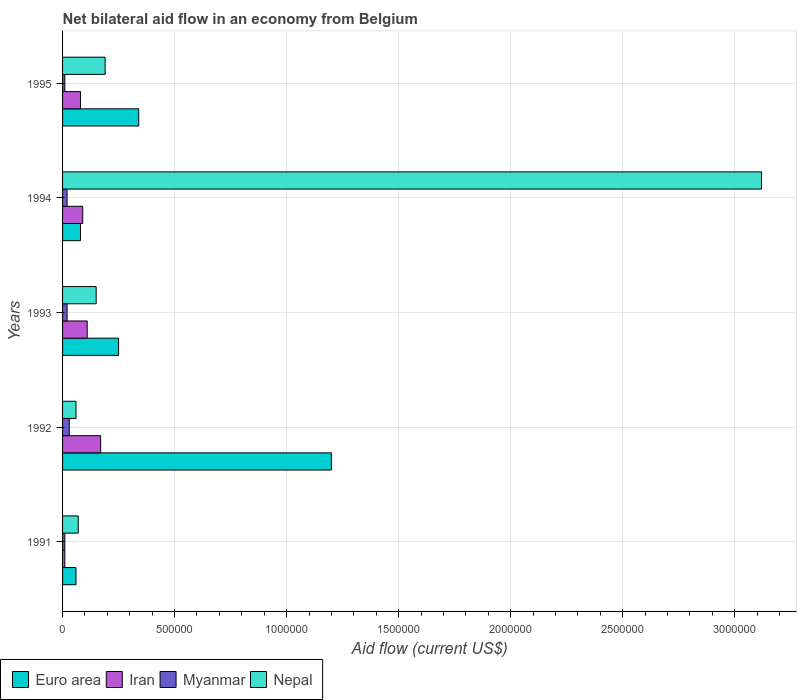How many different coloured bars are there?
Your answer should be compact. 4. How many groups of bars are there?
Your response must be concise. 5. How many bars are there on the 4th tick from the top?
Provide a short and direct response. 4. How many bars are there on the 5th tick from the bottom?
Keep it short and to the point. 4. In how many cases, is the number of bars for a given year not equal to the number of legend labels?
Provide a succinct answer. 0. Across all years, what is the maximum net bilateral aid flow in Nepal?
Make the answer very short. 3.12e+06. Across all years, what is the minimum net bilateral aid flow in Euro area?
Provide a short and direct response. 6.00e+04. In which year was the net bilateral aid flow in Myanmar maximum?
Offer a terse response. 1992. In which year was the net bilateral aid flow in Myanmar minimum?
Offer a terse response. 1991. What is the total net bilateral aid flow in Iran in the graph?
Make the answer very short. 4.60e+05. What is the difference between the net bilateral aid flow in Euro area in 1992 and that in 1995?
Offer a very short reply. 8.60e+05. What is the average net bilateral aid flow in Nepal per year?
Your answer should be very brief. 7.18e+05. What is the ratio of the net bilateral aid flow in Euro area in 1991 to that in 1994?
Provide a short and direct response. 0.75. Is the net bilateral aid flow in Nepal in 1991 less than that in 1994?
Give a very brief answer. Yes. Is the difference between the net bilateral aid flow in Iran in 1994 and 1995 greater than the difference between the net bilateral aid flow in Myanmar in 1994 and 1995?
Provide a short and direct response. No. What is the difference between the highest and the second highest net bilateral aid flow in Euro area?
Provide a short and direct response. 8.60e+05. What is the difference between the highest and the lowest net bilateral aid flow in Iran?
Keep it short and to the point. 1.60e+05. Is it the case that in every year, the sum of the net bilateral aid flow in Euro area and net bilateral aid flow in Myanmar is greater than the sum of net bilateral aid flow in Iran and net bilateral aid flow in Nepal?
Your response must be concise. Yes. What does the 2nd bar from the top in 1994 represents?
Your answer should be very brief. Myanmar. What does the 2nd bar from the bottom in 1993 represents?
Make the answer very short. Iran. Is it the case that in every year, the sum of the net bilateral aid flow in Nepal and net bilateral aid flow in Euro area is greater than the net bilateral aid flow in Iran?
Your answer should be compact. Yes. How many bars are there?
Your answer should be very brief. 20. Are the values on the major ticks of X-axis written in scientific E-notation?
Your response must be concise. No. Does the graph contain any zero values?
Your answer should be compact. No. Does the graph contain grids?
Keep it short and to the point. Yes. How many legend labels are there?
Provide a succinct answer. 4. What is the title of the graph?
Offer a very short reply. Net bilateral aid flow in an economy from Belgium. What is the label or title of the X-axis?
Give a very brief answer. Aid flow (current US$). What is the Aid flow (current US$) in Euro area in 1991?
Offer a very short reply. 6.00e+04. What is the Aid flow (current US$) of Euro area in 1992?
Make the answer very short. 1.20e+06. What is the Aid flow (current US$) in Nepal in 1992?
Offer a terse response. 6.00e+04. What is the Aid flow (current US$) in Euro area in 1993?
Offer a very short reply. 2.50e+05. What is the Aid flow (current US$) in Myanmar in 1993?
Offer a terse response. 2.00e+04. What is the Aid flow (current US$) in Nepal in 1993?
Your response must be concise. 1.50e+05. What is the Aid flow (current US$) of Myanmar in 1994?
Your response must be concise. 2.00e+04. What is the Aid flow (current US$) in Nepal in 1994?
Offer a terse response. 3.12e+06. What is the Aid flow (current US$) in Nepal in 1995?
Give a very brief answer. 1.90e+05. Across all years, what is the maximum Aid flow (current US$) in Euro area?
Ensure brevity in your answer.  1.20e+06. Across all years, what is the maximum Aid flow (current US$) in Myanmar?
Offer a terse response. 3.00e+04. Across all years, what is the maximum Aid flow (current US$) in Nepal?
Your answer should be very brief. 3.12e+06. Across all years, what is the minimum Aid flow (current US$) of Euro area?
Provide a succinct answer. 6.00e+04. Across all years, what is the minimum Aid flow (current US$) of Iran?
Your answer should be compact. 10000. Across all years, what is the minimum Aid flow (current US$) of Nepal?
Your response must be concise. 6.00e+04. What is the total Aid flow (current US$) of Euro area in the graph?
Your answer should be compact. 1.93e+06. What is the total Aid flow (current US$) in Myanmar in the graph?
Your response must be concise. 9.00e+04. What is the total Aid flow (current US$) in Nepal in the graph?
Offer a terse response. 3.59e+06. What is the difference between the Aid flow (current US$) of Euro area in 1991 and that in 1992?
Offer a terse response. -1.14e+06. What is the difference between the Aid flow (current US$) in Iran in 1991 and that in 1992?
Offer a terse response. -1.60e+05. What is the difference between the Aid flow (current US$) of Nepal in 1991 and that in 1993?
Offer a very short reply. -8.00e+04. What is the difference between the Aid flow (current US$) in Euro area in 1991 and that in 1994?
Offer a very short reply. -2.00e+04. What is the difference between the Aid flow (current US$) of Iran in 1991 and that in 1994?
Keep it short and to the point. -8.00e+04. What is the difference between the Aid flow (current US$) in Myanmar in 1991 and that in 1994?
Your answer should be very brief. -10000. What is the difference between the Aid flow (current US$) in Nepal in 1991 and that in 1994?
Your response must be concise. -3.05e+06. What is the difference between the Aid flow (current US$) of Euro area in 1991 and that in 1995?
Make the answer very short. -2.80e+05. What is the difference between the Aid flow (current US$) of Nepal in 1991 and that in 1995?
Offer a terse response. -1.20e+05. What is the difference between the Aid flow (current US$) of Euro area in 1992 and that in 1993?
Provide a succinct answer. 9.50e+05. What is the difference between the Aid flow (current US$) in Iran in 1992 and that in 1993?
Your answer should be compact. 6.00e+04. What is the difference between the Aid flow (current US$) of Nepal in 1992 and that in 1993?
Your answer should be very brief. -9.00e+04. What is the difference between the Aid flow (current US$) in Euro area in 1992 and that in 1994?
Provide a succinct answer. 1.12e+06. What is the difference between the Aid flow (current US$) in Myanmar in 1992 and that in 1994?
Your answer should be very brief. 10000. What is the difference between the Aid flow (current US$) in Nepal in 1992 and that in 1994?
Your answer should be very brief. -3.06e+06. What is the difference between the Aid flow (current US$) in Euro area in 1992 and that in 1995?
Keep it short and to the point. 8.60e+05. What is the difference between the Aid flow (current US$) in Iran in 1993 and that in 1994?
Offer a very short reply. 2.00e+04. What is the difference between the Aid flow (current US$) in Myanmar in 1993 and that in 1994?
Your answer should be compact. 0. What is the difference between the Aid flow (current US$) in Nepal in 1993 and that in 1994?
Give a very brief answer. -2.97e+06. What is the difference between the Aid flow (current US$) of Euro area in 1993 and that in 1995?
Your answer should be compact. -9.00e+04. What is the difference between the Aid flow (current US$) in Iran in 1993 and that in 1995?
Provide a succinct answer. 3.00e+04. What is the difference between the Aid flow (current US$) of Nepal in 1993 and that in 1995?
Provide a short and direct response. -4.00e+04. What is the difference between the Aid flow (current US$) of Iran in 1994 and that in 1995?
Provide a short and direct response. 10000. What is the difference between the Aid flow (current US$) in Nepal in 1994 and that in 1995?
Your answer should be very brief. 2.93e+06. What is the difference between the Aid flow (current US$) in Iran in 1991 and the Aid flow (current US$) in Myanmar in 1992?
Your answer should be compact. -2.00e+04. What is the difference between the Aid flow (current US$) of Iran in 1991 and the Aid flow (current US$) of Nepal in 1992?
Provide a short and direct response. -5.00e+04. What is the difference between the Aid flow (current US$) of Myanmar in 1991 and the Aid flow (current US$) of Nepal in 1992?
Your answer should be compact. -5.00e+04. What is the difference between the Aid flow (current US$) in Euro area in 1991 and the Aid flow (current US$) in Iran in 1993?
Offer a terse response. -5.00e+04. What is the difference between the Aid flow (current US$) of Euro area in 1991 and the Aid flow (current US$) of Myanmar in 1993?
Provide a short and direct response. 4.00e+04. What is the difference between the Aid flow (current US$) in Iran in 1991 and the Aid flow (current US$) in Myanmar in 1993?
Your answer should be very brief. -10000. What is the difference between the Aid flow (current US$) of Iran in 1991 and the Aid flow (current US$) of Nepal in 1993?
Provide a succinct answer. -1.40e+05. What is the difference between the Aid flow (current US$) of Myanmar in 1991 and the Aid flow (current US$) of Nepal in 1993?
Your response must be concise. -1.40e+05. What is the difference between the Aid flow (current US$) of Euro area in 1991 and the Aid flow (current US$) of Iran in 1994?
Your answer should be very brief. -3.00e+04. What is the difference between the Aid flow (current US$) of Euro area in 1991 and the Aid flow (current US$) of Nepal in 1994?
Provide a succinct answer. -3.06e+06. What is the difference between the Aid flow (current US$) of Iran in 1991 and the Aid flow (current US$) of Myanmar in 1994?
Your answer should be compact. -10000. What is the difference between the Aid flow (current US$) in Iran in 1991 and the Aid flow (current US$) in Nepal in 1994?
Ensure brevity in your answer.  -3.11e+06. What is the difference between the Aid flow (current US$) of Myanmar in 1991 and the Aid flow (current US$) of Nepal in 1994?
Offer a very short reply. -3.11e+06. What is the difference between the Aid flow (current US$) in Euro area in 1991 and the Aid flow (current US$) in Iran in 1995?
Your answer should be compact. -2.00e+04. What is the difference between the Aid flow (current US$) in Iran in 1991 and the Aid flow (current US$) in Nepal in 1995?
Give a very brief answer. -1.80e+05. What is the difference between the Aid flow (current US$) in Euro area in 1992 and the Aid flow (current US$) in Iran in 1993?
Your response must be concise. 1.09e+06. What is the difference between the Aid flow (current US$) of Euro area in 1992 and the Aid flow (current US$) of Myanmar in 1993?
Your answer should be very brief. 1.18e+06. What is the difference between the Aid flow (current US$) in Euro area in 1992 and the Aid flow (current US$) in Nepal in 1993?
Provide a short and direct response. 1.05e+06. What is the difference between the Aid flow (current US$) of Iran in 1992 and the Aid flow (current US$) of Myanmar in 1993?
Your answer should be compact. 1.50e+05. What is the difference between the Aid flow (current US$) in Iran in 1992 and the Aid flow (current US$) in Nepal in 1993?
Provide a succinct answer. 2.00e+04. What is the difference between the Aid flow (current US$) of Euro area in 1992 and the Aid flow (current US$) of Iran in 1994?
Provide a short and direct response. 1.11e+06. What is the difference between the Aid flow (current US$) of Euro area in 1992 and the Aid flow (current US$) of Myanmar in 1994?
Give a very brief answer. 1.18e+06. What is the difference between the Aid flow (current US$) in Euro area in 1992 and the Aid flow (current US$) in Nepal in 1994?
Ensure brevity in your answer.  -1.92e+06. What is the difference between the Aid flow (current US$) of Iran in 1992 and the Aid flow (current US$) of Nepal in 1994?
Make the answer very short. -2.95e+06. What is the difference between the Aid flow (current US$) in Myanmar in 1992 and the Aid flow (current US$) in Nepal in 1994?
Make the answer very short. -3.09e+06. What is the difference between the Aid flow (current US$) of Euro area in 1992 and the Aid flow (current US$) of Iran in 1995?
Provide a short and direct response. 1.12e+06. What is the difference between the Aid flow (current US$) of Euro area in 1992 and the Aid flow (current US$) of Myanmar in 1995?
Your answer should be very brief. 1.19e+06. What is the difference between the Aid flow (current US$) of Euro area in 1992 and the Aid flow (current US$) of Nepal in 1995?
Make the answer very short. 1.01e+06. What is the difference between the Aid flow (current US$) in Euro area in 1993 and the Aid flow (current US$) in Iran in 1994?
Provide a succinct answer. 1.60e+05. What is the difference between the Aid flow (current US$) in Euro area in 1993 and the Aid flow (current US$) in Nepal in 1994?
Your response must be concise. -2.87e+06. What is the difference between the Aid flow (current US$) of Iran in 1993 and the Aid flow (current US$) of Nepal in 1994?
Provide a short and direct response. -3.01e+06. What is the difference between the Aid flow (current US$) of Myanmar in 1993 and the Aid flow (current US$) of Nepal in 1994?
Ensure brevity in your answer.  -3.10e+06. What is the difference between the Aid flow (current US$) of Iran in 1993 and the Aid flow (current US$) of Myanmar in 1995?
Offer a very short reply. 1.00e+05. What is the difference between the Aid flow (current US$) of Iran in 1993 and the Aid flow (current US$) of Nepal in 1995?
Keep it short and to the point. -8.00e+04. What is the difference between the Aid flow (current US$) of Euro area in 1994 and the Aid flow (current US$) of Iran in 1995?
Offer a terse response. 0. What is the difference between the Aid flow (current US$) in Euro area in 1994 and the Aid flow (current US$) in Nepal in 1995?
Offer a terse response. -1.10e+05. What is the difference between the Aid flow (current US$) of Iran in 1994 and the Aid flow (current US$) of Myanmar in 1995?
Keep it short and to the point. 8.00e+04. What is the difference between the Aid flow (current US$) in Myanmar in 1994 and the Aid flow (current US$) in Nepal in 1995?
Provide a succinct answer. -1.70e+05. What is the average Aid flow (current US$) in Euro area per year?
Your answer should be very brief. 3.86e+05. What is the average Aid flow (current US$) of Iran per year?
Make the answer very short. 9.20e+04. What is the average Aid flow (current US$) of Myanmar per year?
Give a very brief answer. 1.80e+04. What is the average Aid flow (current US$) in Nepal per year?
Ensure brevity in your answer.  7.18e+05. In the year 1991, what is the difference between the Aid flow (current US$) of Euro area and Aid flow (current US$) of Myanmar?
Ensure brevity in your answer.  5.00e+04. In the year 1991, what is the difference between the Aid flow (current US$) in Myanmar and Aid flow (current US$) in Nepal?
Provide a short and direct response. -6.00e+04. In the year 1992, what is the difference between the Aid flow (current US$) of Euro area and Aid flow (current US$) of Iran?
Give a very brief answer. 1.03e+06. In the year 1992, what is the difference between the Aid flow (current US$) of Euro area and Aid flow (current US$) of Myanmar?
Provide a short and direct response. 1.17e+06. In the year 1992, what is the difference between the Aid flow (current US$) in Euro area and Aid flow (current US$) in Nepal?
Your answer should be very brief. 1.14e+06. In the year 1992, what is the difference between the Aid flow (current US$) of Iran and Aid flow (current US$) of Myanmar?
Keep it short and to the point. 1.40e+05. In the year 1992, what is the difference between the Aid flow (current US$) of Iran and Aid flow (current US$) of Nepal?
Offer a terse response. 1.10e+05. In the year 1992, what is the difference between the Aid flow (current US$) of Myanmar and Aid flow (current US$) of Nepal?
Offer a very short reply. -3.00e+04. In the year 1993, what is the difference between the Aid flow (current US$) in Euro area and Aid flow (current US$) in Iran?
Your answer should be compact. 1.40e+05. In the year 1993, what is the difference between the Aid flow (current US$) of Euro area and Aid flow (current US$) of Nepal?
Give a very brief answer. 1.00e+05. In the year 1993, what is the difference between the Aid flow (current US$) of Iran and Aid flow (current US$) of Myanmar?
Your answer should be compact. 9.00e+04. In the year 1994, what is the difference between the Aid flow (current US$) in Euro area and Aid flow (current US$) in Iran?
Offer a terse response. -10000. In the year 1994, what is the difference between the Aid flow (current US$) in Euro area and Aid flow (current US$) in Nepal?
Keep it short and to the point. -3.04e+06. In the year 1994, what is the difference between the Aid flow (current US$) in Iran and Aid flow (current US$) in Nepal?
Provide a succinct answer. -3.03e+06. In the year 1994, what is the difference between the Aid flow (current US$) in Myanmar and Aid flow (current US$) in Nepal?
Your answer should be very brief. -3.10e+06. In the year 1995, what is the difference between the Aid flow (current US$) of Euro area and Aid flow (current US$) of Myanmar?
Your answer should be compact. 3.30e+05. In the year 1995, what is the difference between the Aid flow (current US$) of Iran and Aid flow (current US$) of Myanmar?
Your answer should be very brief. 7.00e+04. In the year 1995, what is the difference between the Aid flow (current US$) in Iran and Aid flow (current US$) in Nepal?
Give a very brief answer. -1.10e+05. What is the ratio of the Aid flow (current US$) of Iran in 1991 to that in 1992?
Your answer should be very brief. 0.06. What is the ratio of the Aid flow (current US$) in Myanmar in 1991 to that in 1992?
Your answer should be compact. 0.33. What is the ratio of the Aid flow (current US$) in Euro area in 1991 to that in 1993?
Your response must be concise. 0.24. What is the ratio of the Aid flow (current US$) in Iran in 1991 to that in 1993?
Offer a terse response. 0.09. What is the ratio of the Aid flow (current US$) of Myanmar in 1991 to that in 1993?
Ensure brevity in your answer.  0.5. What is the ratio of the Aid flow (current US$) of Nepal in 1991 to that in 1993?
Make the answer very short. 0.47. What is the ratio of the Aid flow (current US$) of Nepal in 1991 to that in 1994?
Make the answer very short. 0.02. What is the ratio of the Aid flow (current US$) in Euro area in 1991 to that in 1995?
Your answer should be very brief. 0.18. What is the ratio of the Aid flow (current US$) of Myanmar in 1991 to that in 1995?
Make the answer very short. 1. What is the ratio of the Aid flow (current US$) in Nepal in 1991 to that in 1995?
Give a very brief answer. 0.37. What is the ratio of the Aid flow (current US$) of Iran in 1992 to that in 1993?
Offer a terse response. 1.55. What is the ratio of the Aid flow (current US$) of Iran in 1992 to that in 1994?
Keep it short and to the point. 1.89. What is the ratio of the Aid flow (current US$) in Nepal in 1992 to that in 1994?
Your response must be concise. 0.02. What is the ratio of the Aid flow (current US$) in Euro area in 1992 to that in 1995?
Offer a very short reply. 3.53. What is the ratio of the Aid flow (current US$) in Iran in 1992 to that in 1995?
Make the answer very short. 2.12. What is the ratio of the Aid flow (current US$) in Myanmar in 1992 to that in 1995?
Provide a short and direct response. 3. What is the ratio of the Aid flow (current US$) in Nepal in 1992 to that in 1995?
Your answer should be very brief. 0.32. What is the ratio of the Aid flow (current US$) of Euro area in 1993 to that in 1994?
Your response must be concise. 3.12. What is the ratio of the Aid flow (current US$) in Iran in 1993 to that in 1994?
Provide a short and direct response. 1.22. What is the ratio of the Aid flow (current US$) of Nepal in 1993 to that in 1994?
Keep it short and to the point. 0.05. What is the ratio of the Aid flow (current US$) in Euro area in 1993 to that in 1995?
Ensure brevity in your answer.  0.74. What is the ratio of the Aid flow (current US$) in Iran in 1993 to that in 1995?
Keep it short and to the point. 1.38. What is the ratio of the Aid flow (current US$) of Nepal in 1993 to that in 1995?
Make the answer very short. 0.79. What is the ratio of the Aid flow (current US$) of Euro area in 1994 to that in 1995?
Provide a short and direct response. 0.24. What is the ratio of the Aid flow (current US$) in Myanmar in 1994 to that in 1995?
Provide a succinct answer. 2. What is the ratio of the Aid flow (current US$) in Nepal in 1994 to that in 1995?
Ensure brevity in your answer.  16.42. What is the difference between the highest and the second highest Aid flow (current US$) in Euro area?
Your answer should be very brief. 8.60e+05. What is the difference between the highest and the second highest Aid flow (current US$) of Myanmar?
Your response must be concise. 10000. What is the difference between the highest and the second highest Aid flow (current US$) in Nepal?
Give a very brief answer. 2.93e+06. What is the difference between the highest and the lowest Aid flow (current US$) in Euro area?
Ensure brevity in your answer.  1.14e+06. What is the difference between the highest and the lowest Aid flow (current US$) of Nepal?
Give a very brief answer. 3.06e+06. 